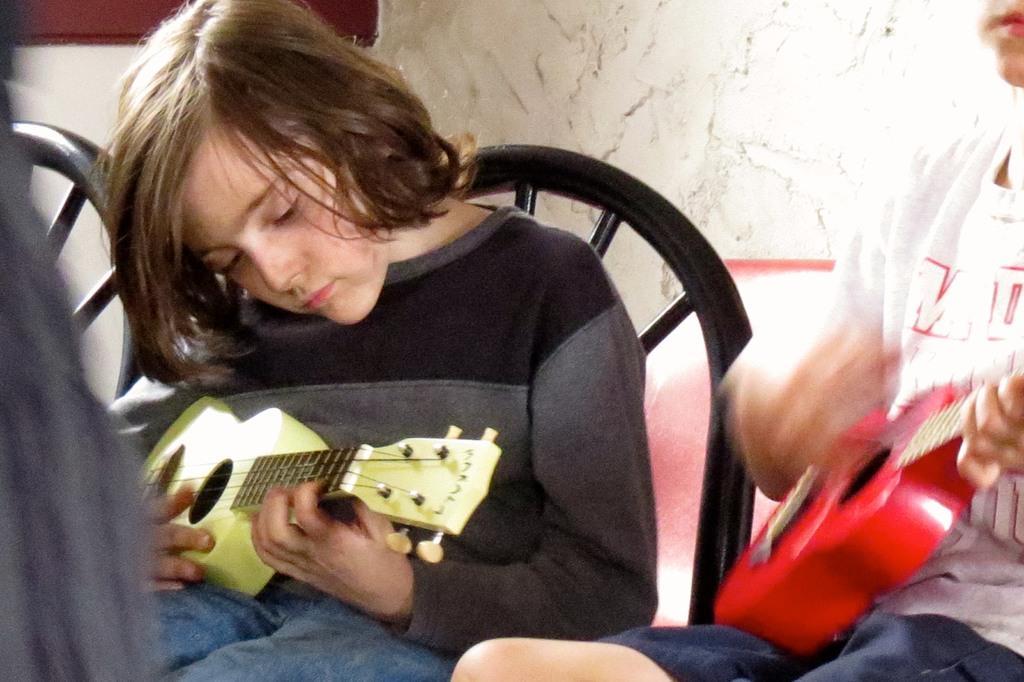Can you describe this image briefly? In this picture we can see few people are seated on the chair, and two persons are playing guitar. 